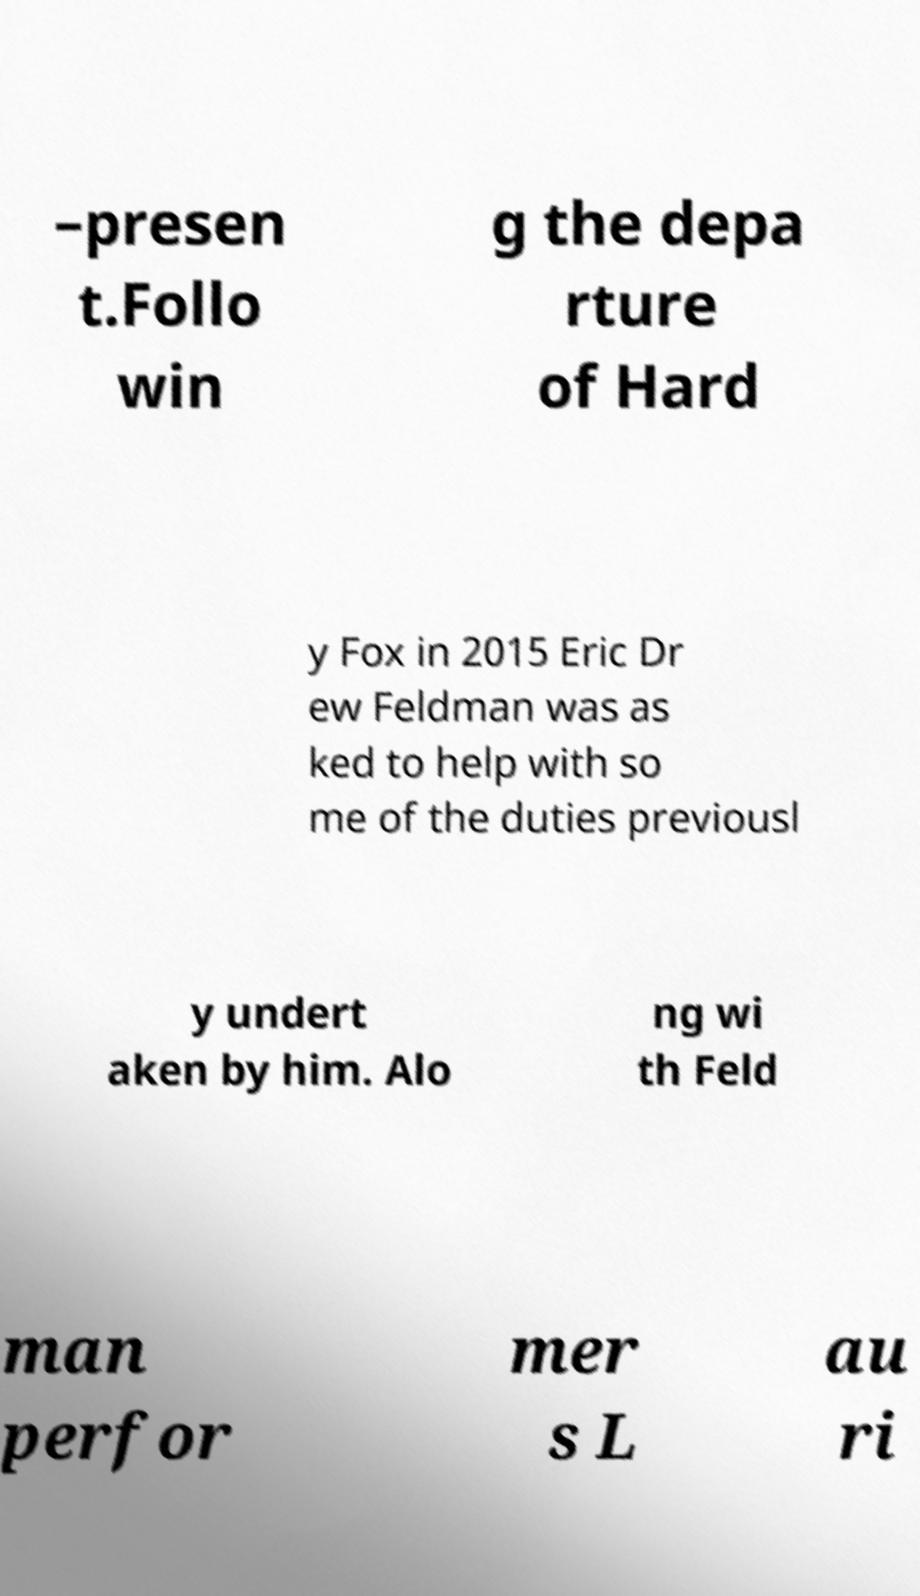Could you extract and type out the text from this image? –presen t.Follo win g the depa rture of Hard y Fox in 2015 Eric Dr ew Feldman was as ked to help with so me of the duties previousl y undert aken by him. Alo ng wi th Feld man perfor mer s L au ri 